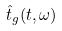<formula> <loc_0><loc_0><loc_500><loc_500>\hat { t } _ { g } ( t , \omega )</formula> 